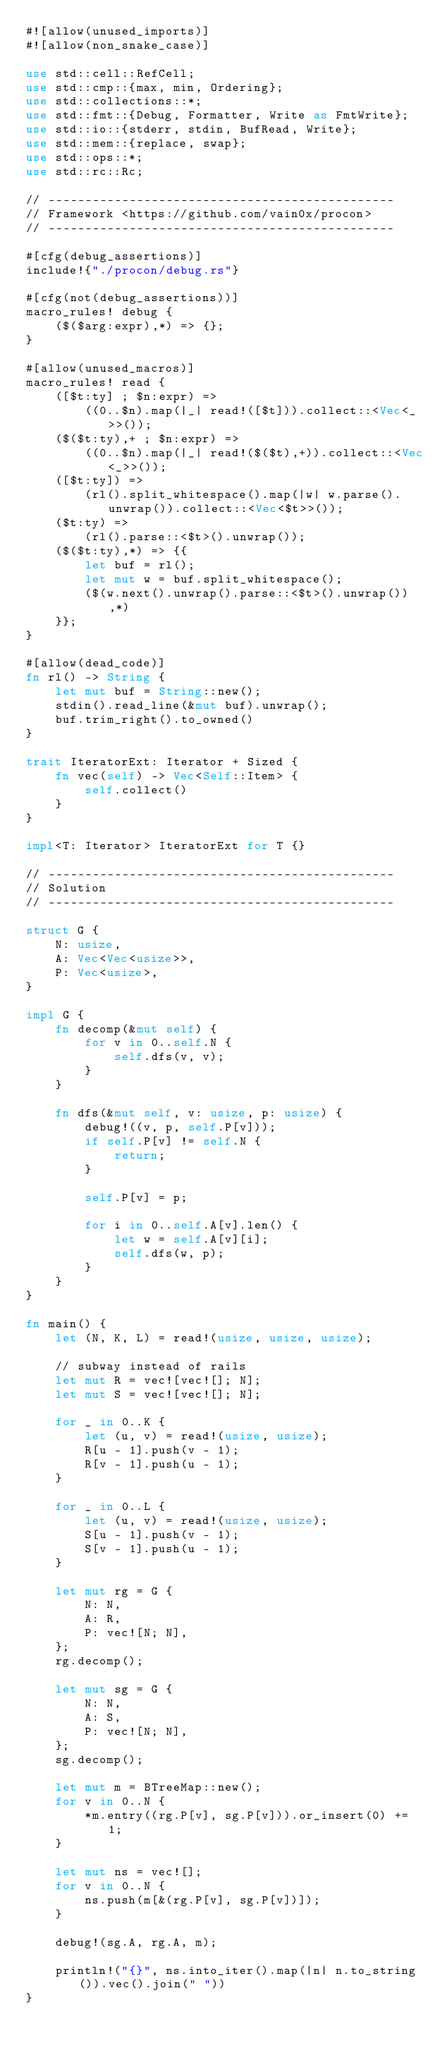Convert code to text. <code><loc_0><loc_0><loc_500><loc_500><_Rust_>#![allow(unused_imports)]
#![allow(non_snake_case)]

use std::cell::RefCell;
use std::cmp::{max, min, Ordering};
use std::collections::*;
use std::fmt::{Debug, Formatter, Write as FmtWrite};
use std::io::{stderr, stdin, BufRead, Write};
use std::mem::{replace, swap};
use std::ops::*;
use std::rc::Rc;

// -----------------------------------------------
// Framework <https://github.com/vain0x/procon>
// -----------------------------------------------

#[cfg(debug_assertions)]
include!{"./procon/debug.rs"}

#[cfg(not(debug_assertions))]
macro_rules! debug {
    ($($arg:expr),*) => {};
}

#[allow(unused_macros)]
macro_rules! read {
    ([$t:ty] ; $n:expr) =>
        ((0..$n).map(|_| read!([$t])).collect::<Vec<_>>());
    ($($t:ty),+ ; $n:expr) =>
        ((0..$n).map(|_| read!($($t),+)).collect::<Vec<_>>());
    ([$t:ty]) =>
        (rl().split_whitespace().map(|w| w.parse().unwrap()).collect::<Vec<$t>>());
    ($t:ty) =>
        (rl().parse::<$t>().unwrap());
    ($($t:ty),*) => {{
        let buf = rl();
        let mut w = buf.split_whitespace();
        ($(w.next().unwrap().parse::<$t>().unwrap()),*)
    }};
}

#[allow(dead_code)]
fn rl() -> String {
    let mut buf = String::new();
    stdin().read_line(&mut buf).unwrap();
    buf.trim_right().to_owned()
}

trait IteratorExt: Iterator + Sized {
    fn vec(self) -> Vec<Self::Item> {
        self.collect()
    }
}

impl<T: Iterator> IteratorExt for T {}

// -----------------------------------------------
// Solution
// -----------------------------------------------

struct G {
    N: usize,
    A: Vec<Vec<usize>>,
    P: Vec<usize>,
}

impl G {
    fn decomp(&mut self) {
        for v in 0..self.N {
            self.dfs(v, v);
        }
    }

    fn dfs(&mut self, v: usize, p: usize) {
        debug!((v, p, self.P[v]));
        if self.P[v] != self.N {
            return;
        }

        self.P[v] = p;

        for i in 0..self.A[v].len() {
            let w = self.A[v][i];
            self.dfs(w, p);
        }
    }
}

fn main() {
    let (N, K, L) = read!(usize, usize, usize);

    // subway instead of rails
    let mut R = vec![vec![]; N];
    let mut S = vec![vec![]; N];

    for _ in 0..K {
        let (u, v) = read!(usize, usize);
        R[u - 1].push(v - 1);
        R[v - 1].push(u - 1);
    }

    for _ in 0..L {
        let (u, v) = read!(usize, usize);
        S[u - 1].push(v - 1);
        S[v - 1].push(u - 1);
    }

    let mut rg = G {
        N: N,
        A: R,
        P: vec![N; N],
    };
    rg.decomp();

    let mut sg = G {
        N: N,
        A: S,
        P: vec![N; N],
    };
    sg.decomp();

    let mut m = BTreeMap::new();
    for v in 0..N {
        *m.entry((rg.P[v], sg.P[v])).or_insert(0) += 1;
    }

    let mut ns = vec![];
    for v in 0..N {
        ns.push(m[&(rg.P[v], sg.P[v])]);
    }

    debug!(sg.A, rg.A, m);

    println!("{}", ns.into_iter().map(|n| n.to_string()).vec().join(" "))
}
</code> 